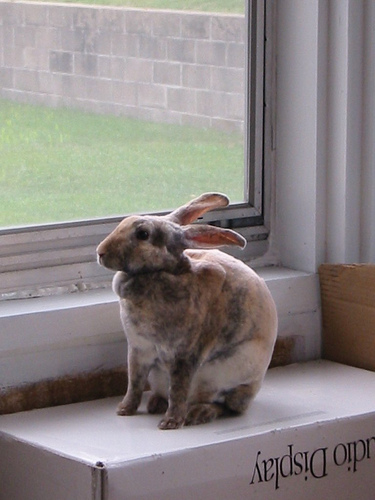<image>
Is the rabbit on the window? No. The rabbit is not positioned on the window. They may be near each other, but the rabbit is not supported by or resting on top of the window. 